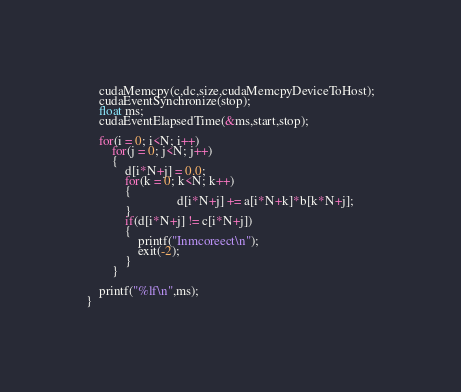Convert code to text. <code><loc_0><loc_0><loc_500><loc_500><_Cuda_>	cudaMemcpy(c,dc,size,cudaMemcpyDeviceToHost);
	cudaEventSynchronize(stop);
	float ms;
	cudaEventElapsedTime(&ms,start,stop);
	
	for(i = 0; i<N; i++)
		for(j = 0; j<N; j++)
		{
			d[i*N+j] = 0.0;
			for(k = 0; k<N; k++)
			{
							d[i*N+j] += a[i*N+k]*b[k*N+j];
			}
			if(d[i*N+j] != c[i*N+j])
			{
				printf("Inmcoreect\n");
				exit(-2);
			}
		}
		
	printf("%lf\n",ms);	
}</code> 